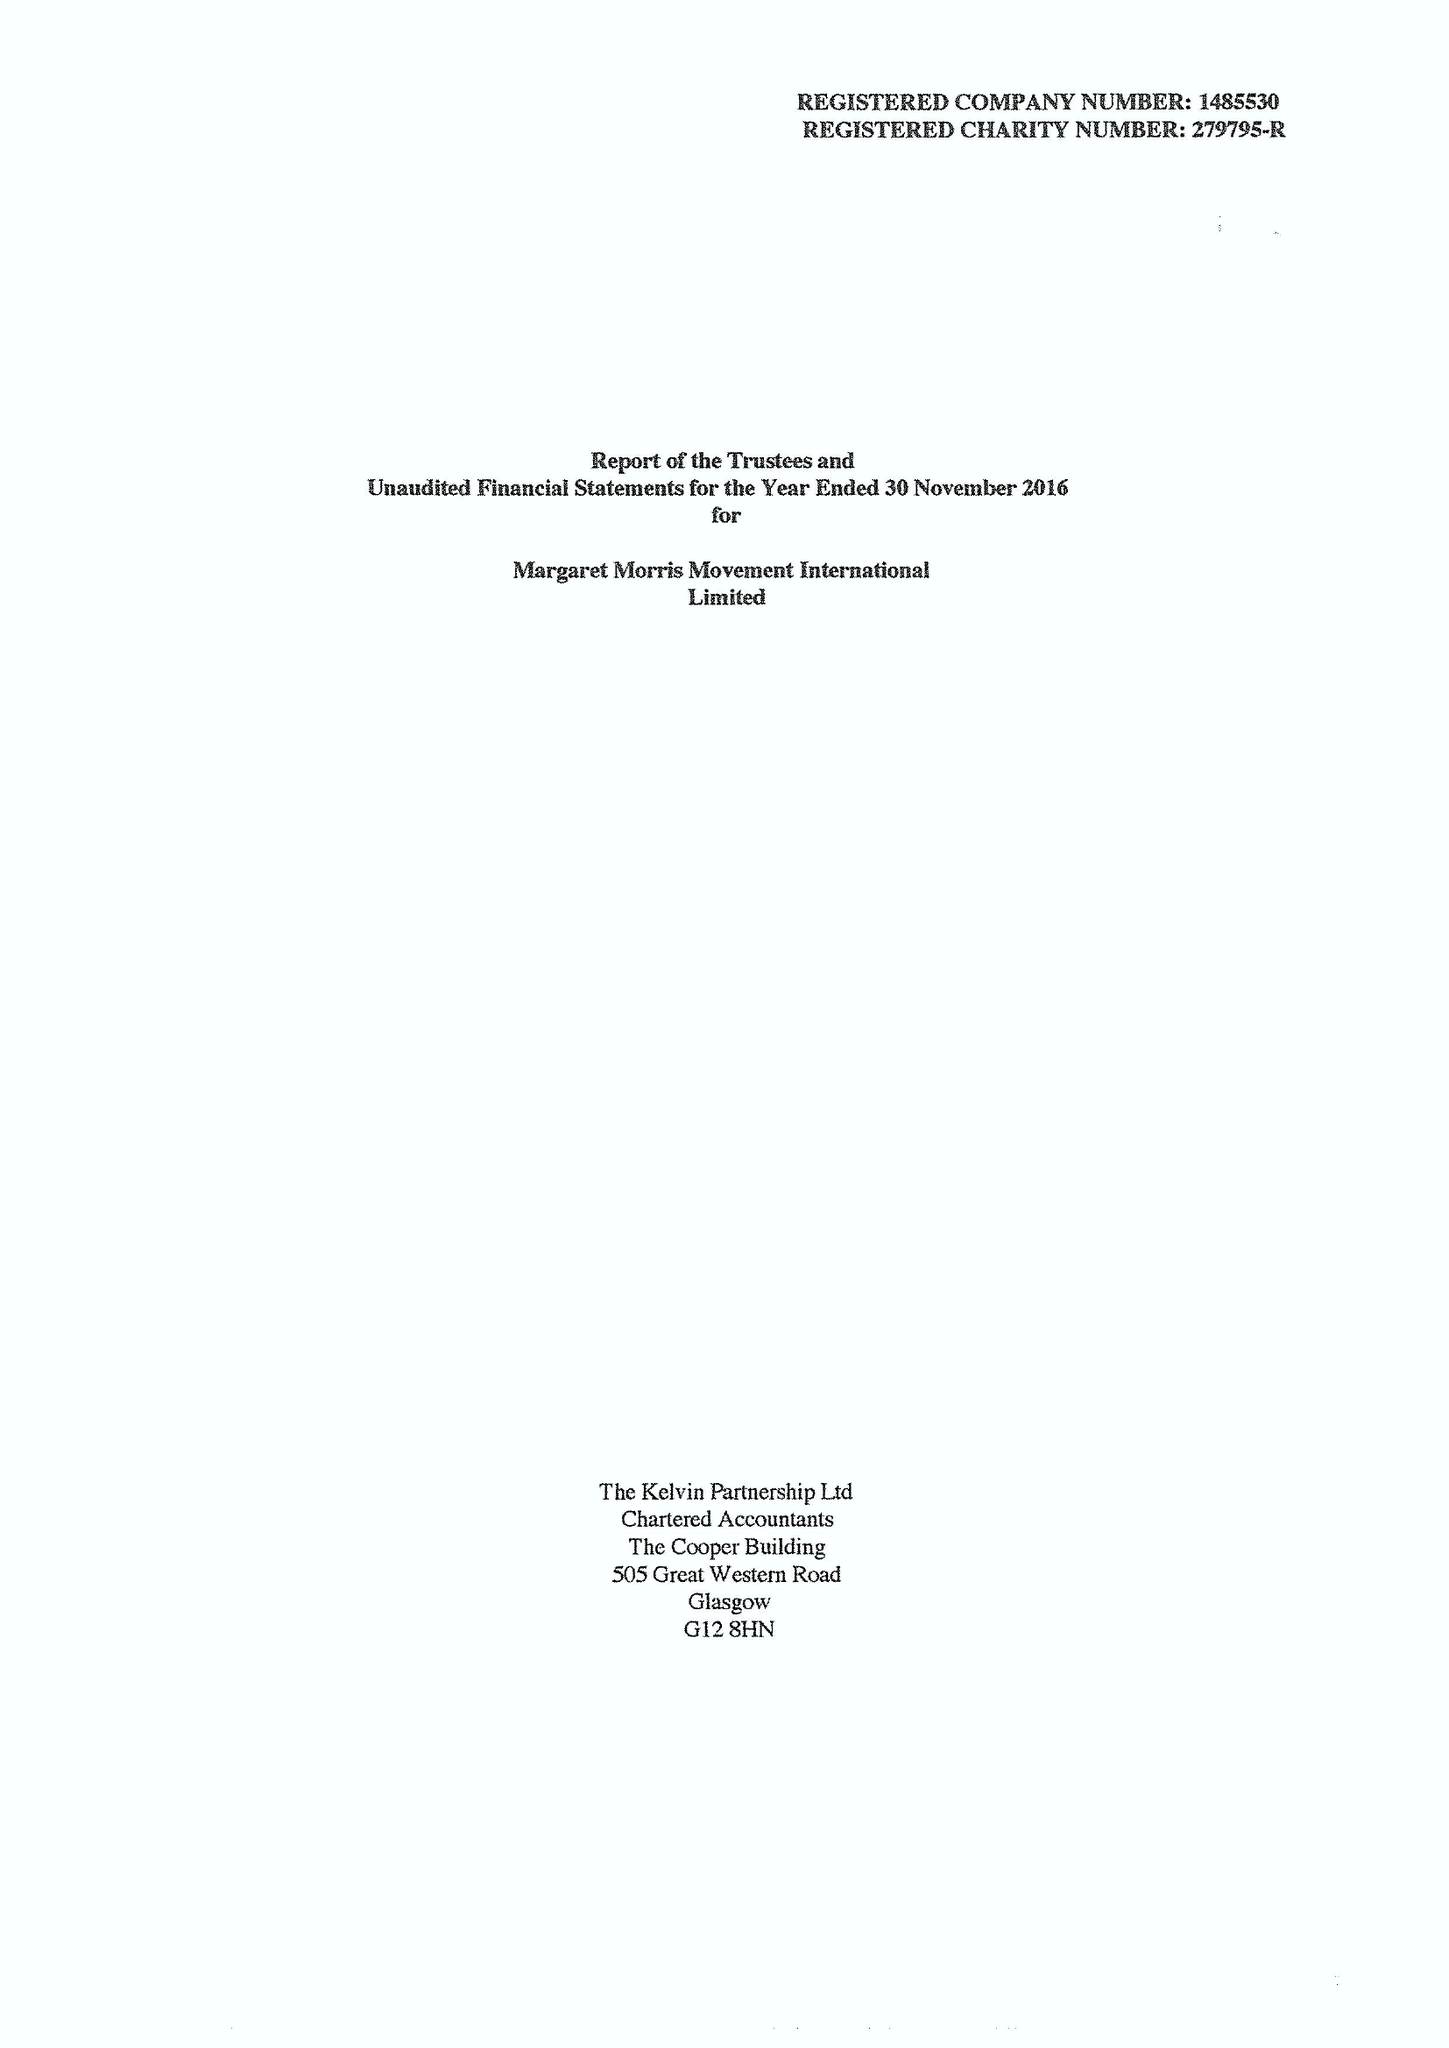What is the value for the report_date?
Answer the question using a single word or phrase. 2016-11-30 